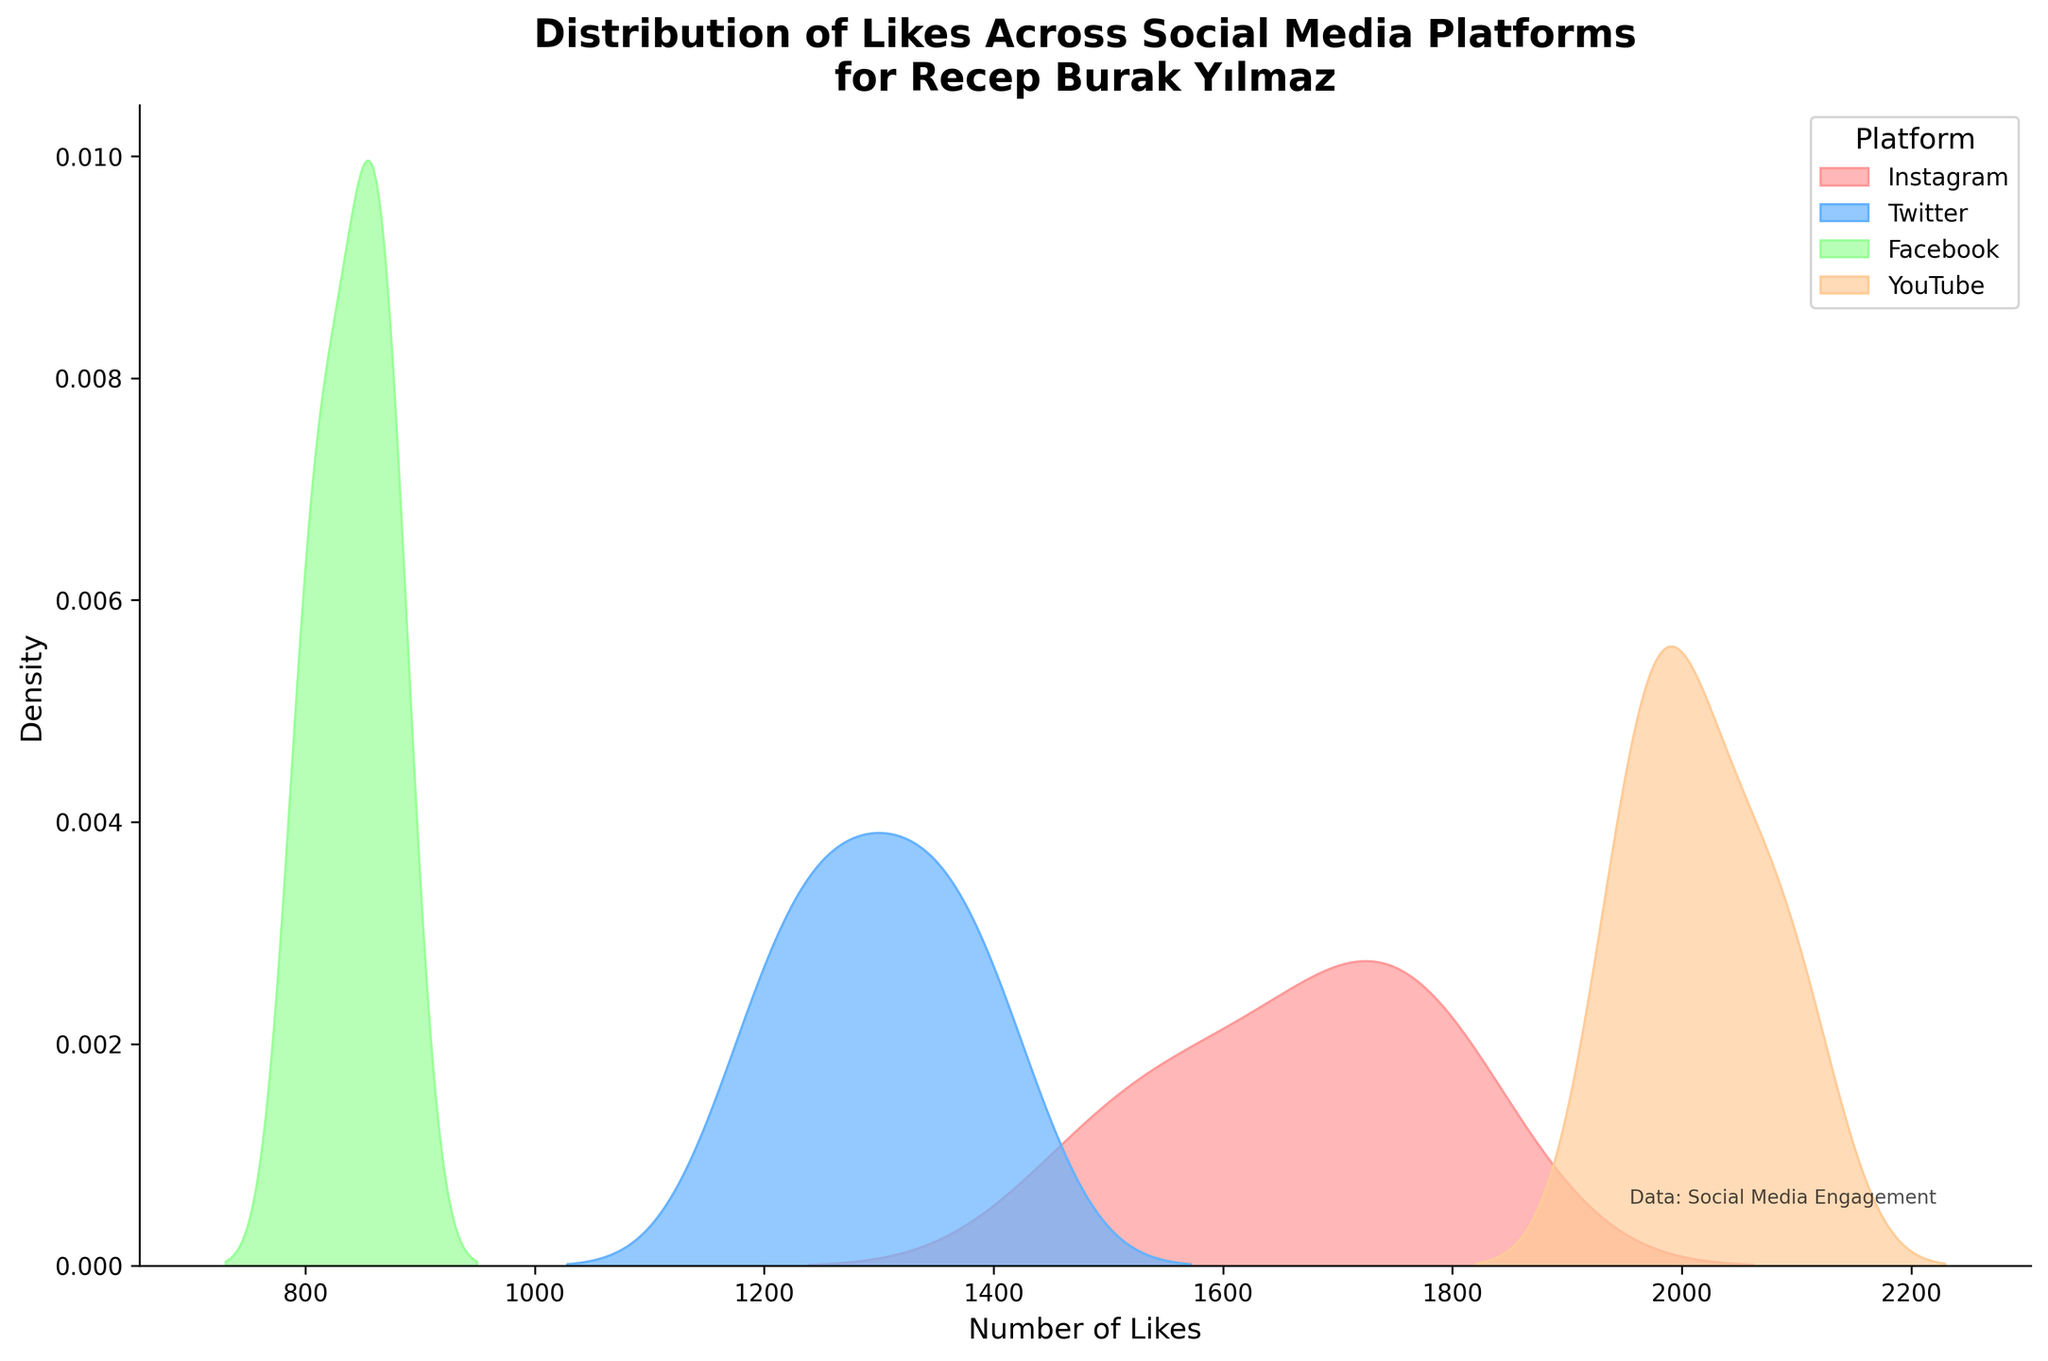What is the title of the plotted figure? The title of the figure is typically written at the top center. Here, it should be the main text that stands out at the top of the plot.
Answer: Distribution of Likes Across Social Media Platforms for Recep Burak Yılmaz What does the x-axis represent in this plot? The x-axis label is usually located below the horizontal line at the bottom of the plot. It indicates the type of data being represented along the axis.
Answer: Number of Likes Which social media platform has the highest density peak for likes? By examining the heights of the density curves, the social media platform with the tallest peak represents the highest density of likes. The legend can help identify the corresponding platform.
Answer: YouTube How do the density curves for Instagram and Twitter compare? We look at the density curves for both Instagram and Twitter. Instagram's curve is more spread out and wider, indicating a higher density of likes in a broader range. Twitter's curve has a lower peak and is narrower, indicating a more concentrated range of likes.
Answer: Instagram has higher and more spread-out density, Twitter has a narrower peak What can you infer about the consistency of likes on Facebook and YouTube? By observing the width and height of the density distributions, a narrower peak indicates higher consistency while a broader spread suggests variability. Facebook's curve is narrow with a lower peak, while YouTube's curve is taller and slightly more spread out, indicating higher consistency in likes.
Answer: Facebook is more consistent, YouTube varies more Can you determine the approximate range of likes for Instagram? To determine the range, observe where the density curve starts rising and where it ends falling. For Instagram, the density starts around 1500 likes and ends around 1800 likes.
Answer: 1500-1800 Which platform shows the most variation in likes? The platform with the broadest density curve represents the most variation. By comparing the width of each curve, YouTube's is the one that spans a larger range.
Answer: YouTube Compare the density peaks of Instagram and Facebook. Which one has a higher density peak? By looking at the height of the density curves, the one with the taller peak has a higher density. Comparing Instagram and Facebook, Instagram's peak is clearly higher.
Answer: Instagram In which density plot does the number of likes appear the least variable? The least variable plot is indicated by the narrowest density curve. Observing the curves, the Facebook plot is the narrowest, suggesting the least variability.
Answer: Facebook 